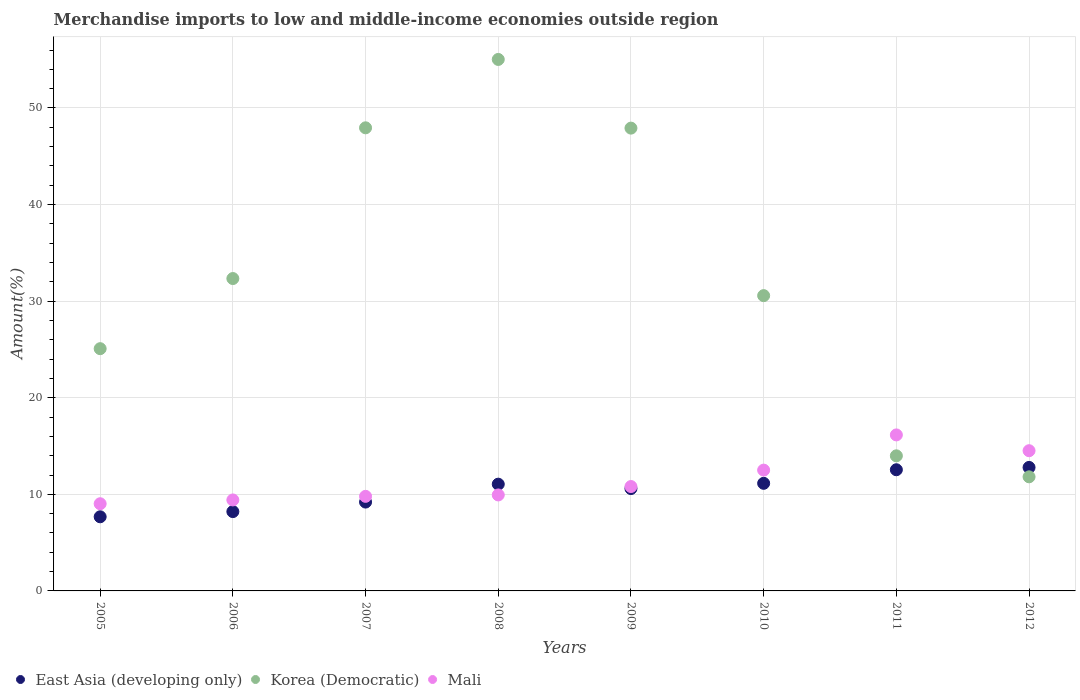How many different coloured dotlines are there?
Your response must be concise. 3. What is the percentage of amount earned from merchandise imports in Korea (Democratic) in 2011?
Make the answer very short. 13.99. Across all years, what is the maximum percentage of amount earned from merchandise imports in Mali?
Offer a very short reply. 16.15. Across all years, what is the minimum percentage of amount earned from merchandise imports in Mali?
Your response must be concise. 9.03. What is the total percentage of amount earned from merchandise imports in Mali in the graph?
Ensure brevity in your answer.  92.15. What is the difference between the percentage of amount earned from merchandise imports in Korea (Democratic) in 2005 and that in 2006?
Your answer should be very brief. -7.26. What is the difference between the percentage of amount earned from merchandise imports in Korea (Democratic) in 2007 and the percentage of amount earned from merchandise imports in Mali in 2009?
Keep it short and to the point. 37.14. What is the average percentage of amount earned from merchandise imports in East Asia (developing only) per year?
Give a very brief answer. 10.4. In the year 2007, what is the difference between the percentage of amount earned from merchandise imports in East Asia (developing only) and percentage of amount earned from merchandise imports in Korea (Democratic)?
Your answer should be very brief. -38.75. What is the ratio of the percentage of amount earned from merchandise imports in Mali in 2006 to that in 2011?
Your answer should be very brief. 0.58. Is the difference between the percentage of amount earned from merchandise imports in East Asia (developing only) in 2006 and 2011 greater than the difference between the percentage of amount earned from merchandise imports in Korea (Democratic) in 2006 and 2011?
Provide a succinct answer. No. What is the difference between the highest and the second highest percentage of amount earned from merchandise imports in Mali?
Your response must be concise. 1.64. What is the difference between the highest and the lowest percentage of amount earned from merchandise imports in East Asia (developing only)?
Provide a short and direct response. 5.11. Is it the case that in every year, the sum of the percentage of amount earned from merchandise imports in Mali and percentage of amount earned from merchandise imports in East Asia (developing only)  is greater than the percentage of amount earned from merchandise imports in Korea (Democratic)?
Your answer should be very brief. No. Is the percentage of amount earned from merchandise imports in Mali strictly less than the percentage of amount earned from merchandise imports in Korea (Democratic) over the years?
Give a very brief answer. No. How many dotlines are there?
Offer a very short reply. 3. Are the values on the major ticks of Y-axis written in scientific E-notation?
Your answer should be compact. No. Where does the legend appear in the graph?
Ensure brevity in your answer.  Bottom left. How many legend labels are there?
Provide a short and direct response. 3. What is the title of the graph?
Provide a succinct answer. Merchandise imports to low and middle-income economies outside region. What is the label or title of the Y-axis?
Your answer should be compact. Amount(%). What is the Amount(%) of East Asia (developing only) in 2005?
Your response must be concise. 7.68. What is the Amount(%) of Korea (Democratic) in 2005?
Your answer should be very brief. 25.08. What is the Amount(%) of Mali in 2005?
Offer a terse response. 9.03. What is the Amount(%) of East Asia (developing only) in 2006?
Offer a terse response. 8.21. What is the Amount(%) of Korea (Democratic) in 2006?
Offer a very short reply. 32.34. What is the Amount(%) of Mali in 2006?
Offer a very short reply. 9.42. What is the Amount(%) of East Asia (developing only) in 2007?
Provide a succinct answer. 9.2. What is the Amount(%) in Korea (Democratic) in 2007?
Your response must be concise. 47.94. What is the Amount(%) in Mali in 2007?
Your answer should be very brief. 9.79. What is the Amount(%) in East Asia (developing only) in 2008?
Provide a succinct answer. 11.05. What is the Amount(%) in Korea (Democratic) in 2008?
Make the answer very short. 55.02. What is the Amount(%) of Mali in 2008?
Offer a very short reply. 9.94. What is the Amount(%) in East Asia (developing only) in 2009?
Provide a succinct answer. 10.6. What is the Amount(%) of Korea (Democratic) in 2009?
Your answer should be compact. 47.91. What is the Amount(%) of Mali in 2009?
Offer a very short reply. 10.81. What is the Amount(%) of East Asia (developing only) in 2010?
Provide a succinct answer. 11.14. What is the Amount(%) in Korea (Democratic) in 2010?
Offer a terse response. 30.57. What is the Amount(%) in Mali in 2010?
Give a very brief answer. 12.51. What is the Amount(%) of East Asia (developing only) in 2011?
Give a very brief answer. 12.54. What is the Amount(%) of Korea (Democratic) in 2011?
Your answer should be very brief. 13.99. What is the Amount(%) of Mali in 2011?
Give a very brief answer. 16.15. What is the Amount(%) of East Asia (developing only) in 2012?
Make the answer very short. 12.79. What is the Amount(%) of Korea (Democratic) in 2012?
Keep it short and to the point. 11.81. What is the Amount(%) in Mali in 2012?
Provide a succinct answer. 14.52. Across all years, what is the maximum Amount(%) in East Asia (developing only)?
Offer a very short reply. 12.79. Across all years, what is the maximum Amount(%) in Korea (Democratic)?
Your answer should be compact. 55.02. Across all years, what is the maximum Amount(%) in Mali?
Your response must be concise. 16.15. Across all years, what is the minimum Amount(%) in East Asia (developing only)?
Provide a short and direct response. 7.68. Across all years, what is the minimum Amount(%) in Korea (Democratic)?
Make the answer very short. 11.81. Across all years, what is the minimum Amount(%) of Mali?
Provide a short and direct response. 9.03. What is the total Amount(%) in East Asia (developing only) in the graph?
Make the answer very short. 83.2. What is the total Amount(%) of Korea (Democratic) in the graph?
Your answer should be very brief. 264.67. What is the total Amount(%) of Mali in the graph?
Keep it short and to the point. 92.15. What is the difference between the Amount(%) in East Asia (developing only) in 2005 and that in 2006?
Your answer should be compact. -0.54. What is the difference between the Amount(%) in Korea (Democratic) in 2005 and that in 2006?
Your response must be concise. -7.26. What is the difference between the Amount(%) in Mali in 2005 and that in 2006?
Your answer should be compact. -0.39. What is the difference between the Amount(%) in East Asia (developing only) in 2005 and that in 2007?
Offer a terse response. -1.52. What is the difference between the Amount(%) in Korea (Democratic) in 2005 and that in 2007?
Your answer should be compact. -22.86. What is the difference between the Amount(%) in Mali in 2005 and that in 2007?
Your answer should be compact. -0.77. What is the difference between the Amount(%) of East Asia (developing only) in 2005 and that in 2008?
Offer a terse response. -3.38. What is the difference between the Amount(%) of Korea (Democratic) in 2005 and that in 2008?
Offer a very short reply. -29.94. What is the difference between the Amount(%) of Mali in 2005 and that in 2008?
Your answer should be very brief. -0.91. What is the difference between the Amount(%) in East Asia (developing only) in 2005 and that in 2009?
Keep it short and to the point. -2.92. What is the difference between the Amount(%) in Korea (Democratic) in 2005 and that in 2009?
Ensure brevity in your answer.  -22.83. What is the difference between the Amount(%) of Mali in 2005 and that in 2009?
Ensure brevity in your answer.  -1.78. What is the difference between the Amount(%) of East Asia (developing only) in 2005 and that in 2010?
Offer a terse response. -3.46. What is the difference between the Amount(%) in Korea (Democratic) in 2005 and that in 2010?
Provide a short and direct response. -5.49. What is the difference between the Amount(%) in Mali in 2005 and that in 2010?
Provide a short and direct response. -3.48. What is the difference between the Amount(%) of East Asia (developing only) in 2005 and that in 2011?
Provide a short and direct response. -4.87. What is the difference between the Amount(%) of Korea (Democratic) in 2005 and that in 2011?
Offer a terse response. 11.09. What is the difference between the Amount(%) in Mali in 2005 and that in 2011?
Provide a short and direct response. -7.13. What is the difference between the Amount(%) of East Asia (developing only) in 2005 and that in 2012?
Give a very brief answer. -5.11. What is the difference between the Amount(%) in Korea (Democratic) in 2005 and that in 2012?
Your answer should be compact. 13.27. What is the difference between the Amount(%) of Mali in 2005 and that in 2012?
Keep it short and to the point. -5.49. What is the difference between the Amount(%) in East Asia (developing only) in 2006 and that in 2007?
Provide a succinct answer. -0.99. What is the difference between the Amount(%) of Korea (Democratic) in 2006 and that in 2007?
Your answer should be very brief. -15.6. What is the difference between the Amount(%) of Mali in 2006 and that in 2007?
Your answer should be very brief. -0.37. What is the difference between the Amount(%) in East Asia (developing only) in 2006 and that in 2008?
Your response must be concise. -2.84. What is the difference between the Amount(%) in Korea (Democratic) in 2006 and that in 2008?
Your answer should be compact. -22.68. What is the difference between the Amount(%) of Mali in 2006 and that in 2008?
Your answer should be compact. -0.52. What is the difference between the Amount(%) of East Asia (developing only) in 2006 and that in 2009?
Keep it short and to the point. -2.39. What is the difference between the Amount(%) in Korea (Democratic) in 2006 and that in 2009?
Provide a succinct answer. -15.57. What is the difference between the Amount(%) in Mali in 2006 and that in 2009?
Provide a short and direct response. -1.39. What is the difference between the Amount(%) of East Asia (developing only) in 2006 and that in 2010?
Your answer should be compact. -2.93. What is the difference between the Amount(%) in Korea (Democratic) in 2006 and that in 2010?
Provide a succinct answer. 1.77. What is the difference between the Amount(%) of Mali in 2006 and that in 2010?
Provide a succinct answer. -3.09. What is the difference between the Amount(%) in East Asia (developing only) in 2006 and that in 2011?
Offer a very short reply. -4.33. What is the difference between the Amount(%) of Korea (Democratic) in 2006 and that in 2011?
Your response must be concise. 18.35. What is the difference between the Amount(%) of Mali in 2006 and that in 2011?
Offer a terse response. -6.73. What is the difference between the Amount(%) in East Asia (developing only) in 2006 and that in 2012?
Your answer should be very brief. -4.57. What is the difference between the Amount(%) of Korea (Democratic) in 2006 and that in 2012?
Give a very brief answer. 20.53. What is the difference between the Amount(%) in Mali in 2006 and that in 2012?
Provide a short and direct response. -5.1. What is the difference between the Amount(%) in East Asia (developing only) in 2007 and that in 2008?
Your response must be concise. -1.85. What is the difference between the Amount(%) of Korea (Democratic) in 2007 and that in 2008?
Your answer should be compact. -7.08. What is the difference between the Amount(%) in Mali in 2007 and that in 2008?
Keep it short and to the point. -0.15. What is the difference between the Amount(%) of East Asia (developing only) in 2007 and that in 2009?
Make the answer very short. -1.4. What is the difference between the Amount(%) of Korea (Democratic) in 2007 and that in 2009?
Your answer should be very brief. 0.03. What is the difference between the Amount(%) of Mali in 2007 and that in 2009?
Ensure brevity in your answer.  -1.02. What is the difference between the Amount(%) of East Asia (developing only) in 2007 and that in 2010?
Give a very brief answer. -1.94. What is the difference between the Amount(%) in Korea (Democratic) in 2007 and that in 2010?
Provide a succinct answer. 17.37. What is the difference between the Amount(%) of Mali in 2007 and that in 2010?
Ensure brevity in your answer.  -2.72. What is the difference between the Amount(%) in East Asia (developing only) in 2007 and that in 2011?
Your response must be concise. -3.35. What is the difference between the Amount(%) of Korea (Democratic) in 2007 and that in 2011?
Make the answer very short. 33.96. What is the difference between the Amount(%) of Mali in 2007 and that in 2011?
Provide a succinct answer. -6.36. What is the difference between the Amount(%) of East Asia (developing only) in 2007 and that in 2012?
Ensure brevity in your answer.  -3.59. What is the difference between the Amount(%) in Korea (Democratic) in 2007 and that in 2012?
Your answer should be compact. 36.13. What is the difference between the Amount(%) of Mali in 2007 and that in 2012?
Offer a very short reply. -4.73. What is the difference between the Amount(%) of East Asia (developing only) in 2008 and that in 2009?
Offer a very short reply. 0.46. What is the difference between the Amount(%) of Korea (Democratic) in 2008 and that in 2009?
Provide a succinct answer. 7.11. What is the difference between the Amount(%) in Mali in 2008 and that in 2009?
Your answer should be compact. -0.87. What is the difference between the Amount(%) of East Asia (developing only) in 2008 and that in 2010?
Your answer should be very brief. -0.09. What is the difference between the Amount(%) of Korea (Democratic) in 2008 and that in 2010?
Provide a short and direct response. 24.45. What is the difference between the Amount(%) in Mali in 2008 and that in 2010?
Offer a terse response. -2.57. What is the difference between the Amount(%) of East Asia (developing only) in 2008 and that in 2011?
Your answer should be very brief. -1.49. What is the difference between the Amount(%) in Korea (Democratic) in 2008 and that in 2011?
Provide a short and direct response. 41.04. What is the difference between the Amount(%) in Mali in 2008 and that in 2011?
Your response must be concise. -6.21. What is the difference between the Amount(%) in East Asia (developing only) in 2008 and that in 2012?
Your answer should be very brief. -1.73. What is the difference between the Amount(%) of Korea (Democratic) in 2008 and that in 2012?
Give a very brief answer. 43.21. What is the difference between the Amount(%) in Mali in 2008 and that in 2012?
Your answer should be compact. -4.58. What is the difference between the Amount(%) in East Asia (developing only) in 2009 and that in 2010?
Provide a short and direct response. -0.54. What is the difference between the Amount(%) of Korea (Democratic) in 2009 and that in 2010?
Make the answer very short. 17.34. What is the difference between the Amount(%) of East Asia (developing only) in 2009 and that in 2011?
Your answer should be very brief. -1.95. What is the difference between the Amount(%) of Korea (Democratic) in 2009 and that in 2011?
Your response must be concise. 33.93. What is the difference between the Amount(%) of Mali in 2009 and that in 2011?
Offer a terse response. -5.34. What is the difference between the Amount(%) in East Asia (developing only) in 2009 and that in 2012?
Offer a terse response. -2.19. What is the difference between the Amount(%) in Korea (Democratic) in 2009 and that in 2012?
Offer a terse response. 36.1. What is the difference between the Amount(%) of Mali in 2009 and that in 2012?
Offer a terse response. -3.71. What is the difference between the Amount(%) of East Asia (developing only) in 2010 and that in 2011?
Ensure brevity in your answer.  -1.41. What is the difference between the Amount(%) in Korea (Democratic) in 2010 and that in 2011?
Offer a terse response. 16.59. What is the difference between the Amount(%) of Mali in 2010 and that in 2011?
Provide a short and direct response. -3.64. What is the difference between the Amount(%) in East Asia (developing only) in 2010 and that in 2012?
Make the answer very short. -1.65. What is the difference between the Amount(%) in Korea (Democratic) in 2010 and that in 2012?
Your response must be concise. 18.76. What is the difference between the Amount(%) in Mali in 2010 and that in 2012?
Your answer should be compact. -2.01. What is the difference between the Amount(%) in East Asia (developing only) in 2011 and that in 2012?
Your response must be concise. -0.24. What is the difference between the Amount(%) of Korea (Democratic) in 2011 and that in 2012?
Your answer should be very brief. 2.17. What is the difference between the Amount(%) of Mali in 2011 and that in 2012?
Your response must be concise. 1.64. What is the difference between the Amount(%) of East Asia (developing only) in 2005 and the Amount(%) of Korea (Democratic) in 2006?
Your response must be concise. -24.66. What is the difference between the Amount(%) in East Asia (developing only) in 2005 and the Amount(%) in Mali in 2006?
Give a very brief answer. -1.74. What is the difference between the Amount(%) of Korea (Democratic) in 2005 and the Amount(%) of Mali in 2006?
Provide a succinct answer. 15.66. What is the difference between the Amount(%) of East Asia (developing only) in 2005 and the Amount(%) of Korea (Democratic) in 2007?
Give a very brief answer. -40.27. What is the difference between the Amount(%) in East Asia (developing only) in 2005 and the Amount(%) in Mali in 2007?
Keep it short and to the point. -2.12. What is the difference between the Amount(%) of Korea (Democratic) in 2005 and the Amount(%) of Mali in 2007?
Give a very brief answer. 15.29. What is the difference between the Amount(%) in East Asia (developing only) in 2005 and the Amount(%) in Korea (Democratic) in 2008?
Your response must be concise. -47.35. What is the difference between the Amount(%) of East Asia (developing only) in 2005 and the Amount(%) of Mali in 2008?
Offer a very short reply. -2.26. What is the difference between the Amount(%) of Korea (Democratic) in 2005 and the Amount(%) of Mali in 2008?
Your answer should be compact. 15.14. What is the difference between the Amount(%) in East Asia (developing only) in 2005 and the Amount(%) in Korea (Democratic) in 2009?
Provide a short and direct response. -40.24. What is the difference between the Amount(%) of East Asia (developing only) in 2005 and the Amount(%) of Mali in 2009?
Provide a succinct answer. -3.13. What is the difference between the Amount(%) in Korea (Democratic) in 2005 and the Amount(%) in Mali in 2009?
Give a very brief answer. 14.27. What is the difference between the Amount(%) in East Asia (developing only) in 2005 and the Amount(%) in Korea (Democratic) in 2010?
Provide a succinct answer. -22.9. What is the difference between the Amount(%) of East Asia (developing only) in 2005 and the Amount(%) of Mali in 2010?
Offer a terse response. -4.83. What is the difference between the Amount(%) in Korea (Democratic) in 2005 and the Amount(%) in Mali in 2010?
Offer a very short reply. 12.57. What is the difference between the Amount(%) of East Asia (developing only) in 2005 and the Amount(%) of Korea (Democratic) in 2011?
Give a very brief answer. -6.31. What is the difference between the Amount(%) in East Asia (developing only) in 2005 and the Amount(%) in Mali in 2011?
Provide a succinct answer. -8.48. What is the difference between the Amount(%) of Korea (Democratic) in 2005 and the Amount(%) of Mali in 2011?
Your answer should be very brief. 8.93. What is the difference between the Amount(%) in East Asia (developing only) in 2005 and the Amount(%) in Korea (Democratic) in 2012?
Your answer should be very brief. -4.14. What is the difference between the Amount(%) in East Asia (developing only) in 2005 and the Amount(%) in Mali in 2012?
Give a very brief answer. -6.84. What is the difference between the Amount(%) in Korea (Democratic) in 2005 and the Amount(%) in Mali in 2012?
Keep it short and to the point. 10.56. What is the difference between the Amount(%) in East Asia (developing only) in 2006 and the Amount(%) in Korea (Democratic) in 2007?
Your response must be concise. -39.73. What is the difference between the Amount(%) in East Asia (developing only) in 2006 and the Amount(%) in Mali in 2007?
Your answer should be very brief. -1.58. What is the difference between the Amount(%) of Korea (Democratic) in 2006 and the Amount(%) of Mali in 2007?
Your response must be concise. 22.55. What is the difference between the Amount(%) in East Asia (developing only) in 2006 and the Amount(%) in Korea (Democratic) in 2008?
Offer a very short reply. -46.81. What is the difference between the Amount(%) in East Asia (developing only) in 2006 and the Amount(%) in Mali in 2008?
Provide a short and direct response. -1.73. What is the difference between the Amount(%) in Korea (Democratic) in 2006 and the Amount(%) in Mali in 2008?
Your response must be concise. 22.4. What is the difference between the Amount(%) of East Asia (developing only) in 2006 and the Amount(%) of Korea (Democratic) in 2009?
Provide a short and direct response. -39.7. What is the difference between the Amount(%) in East Asia (developing only) in 2006 and the Amount(%) in Mali in 2009?
Provide a succinct answer. -2.6. What is the difference between the Amount(%) of Korea (Democratic) in 2006 and the Amount(%) of Mali in 2009?
Keep it short and to the point. 21.53. What is the difference between the Amount(%) of East Asia (developing only) in 2006 and the Amount(%) of Korea (Democratic) in 2010?
Offer a very short reply. -22.36. What is the difference between the Amount(%) of East Asia (developing only) in 2006 and the Amount(%) of Mali in 2010?
Your response must be concise. -4.3. What is the difference between the Amount(%) of Korea (Democratic) in 2006 and the Amount(%) of Mali in 2010?
Provide a succinct answer. 19.83. What is the difference between the Amount(%) in East Asia (developing only) in 2006 and the Amount(%) in Korea (Democratic) in 2011?
Keep it short and to the point. -5.77. What is the difference between the Amount(%) of East Asia (developing only) in 2006 and the Amount(%) of Mali in 2011?
Provide a succinct answer. -7.94. What is the difference between the Amount(%) in Korea (Democratic) in 2006 and the Amount(%) in Mali in 2011?
Offer a terse response. 16.19. What is the difference between the Amount(%) in East Asia (developing only) in 2006 and the Amount(%) in Korea (Democratic) in 2012?
Keep it short and to the point. -3.6. What is the difference between the Amount(%) in East Asia (developing only) in 2006 and the Amount(%) in Mali in 2012?
Your answer should be compact. -6.3. What is the difference between the Amount(%) of Korea (Democratic) in 2006 and the Amount(%) of Mali in 2012?
Your answer should be very brief. 17.82. What is the difference between the Amount(%) of East Asia (developing only) in 2007 and the Amount(%) of Korea (Democratic) in 2008?
Offer a very short reply. -45.82. What is the difference between the Amount(%) in East Asia (developing only) in 2007 and the Amount(%) in Mali in 2008?
Offer a very short reply. -0.74. What is the difference between the Amount(%) in Korea (Democratic) in 2007 and the Amount(%) in Mali in 2008?
Make the answer very short. 38.01. What is the difference between the Amount(%) in East Asia (developing only) in 2007 and the Amount(%) in Korea (Democratic) in 2009?
Give a very brief answer. -38.71. What is the difference between the Amount(%) in East Asia (developing only) in 2007 and the Amount(%) in Mali in 2009?
Provide a succinct answer. -1.61. What is the difference between the Amount(%) in Korea (Democratic) in 2007 and the Amount(%) in Mali in 2009?
Your answer should be very brief. 37.14. What is the difference between the Amount(%) of East Asia (developing only) in 2007 and the Amount(%) of Korea (Democratic) in 2010?
Keep it short and to the point. -21.37. What is the difference between the Amount(%) in East Asia (developing only) in 2007 and the Amount(%) in Mali in 2010?
Your response must be concise. -3.31. What is the difference between the Amount(%) of Korea (Democratic) in 2007 and the Amount(%) of Mali in 2010?
Make the answer very short. 35.44. What is the difference between the Amount(%) in East Asia (developing only) in 2007 and the Amount(%) in Korea (Democratic) in 2011?
Your answer should be very brief. -4.79. What is the difference between the Amount(%) in East Asia (developing only) in 2007 and the Amount(%) in Mali in 2011?
Offer a terse response. -6.95. What is the difference between the Amount(%) in Korea (Democratic) in 2007 and the Amount(%) in Mali in 2011?
Offer a terse response. 31.79. What is the difference between the Amount(%) of East Asia (developing only) in 2007 and the Amount(%) of Korea (Democratic) in 2012?
Offer a terse response. -2.61. What is the difference between the Amount(%) in East Asia (developing only) in 2007 and the Amount(%) in Mali in 2012?
Offer a very short reply. -5.32. What is the difference between the Amount(%) in Korea (Democratic) in 2007 and the Amount(%) in Mali in 2012?
Your answer should be compact. 33.43. What is the difference between the Amount(%) of East Asia (developing only) in 2008 and the Amount(%) of Korea (Democratic) in 2009?
Your answer should be compact. -36.86. What is the difference between the Amount(%) in East Asia (developing only) in 2008 and the Amount(%) in Mali in 2009?
Your answer should be compact. 0.25. What is the difference between the Amount(%) in Korea (Democratic) in 2008 and the Amount(%) in Mali in 2009?
Give a very brief answer. 44.22. What is the difference between the Amount(%) of East Asia (developing only) in 2008 and the Amount(%) of Korea (Democratic) in 2010?
Your response must be concise. -19.52. What is the difference between the Amount(%) in East Asia (developing only) in 2008 and the Amount(%) in Mali in 2010?
Your response must be concise. -1.45. What is the difference between the Amount(%) in Korea (Democratic) in 2008 and the Amount(%) in Mali in 2010?
Provide a short and direct response. 42.52. What is the difference between the Amount(%) in East Asia (developing only) in 2008 and the Amount(%) in Korea (Democratic) in 2011?
Make the answer very short. -2.93. What is the difference between the Amount(%) in East Asia (developing only) in 2008 and the Amount(%) in Mali in 2011?
Your response must be concise. -5.1. What is the difference between the Amount(%) in Korea (Democratic) in 2008 and the Amount(%) in Mali in 2011?
Your answer should be compact. 38.87. What is the difference between the Amount(%) in East Asia (developing only) in 2008 and the Amount(%) in Korea (Democratic) in 2012?
Your answer should be compact. -0.76. What is the difference between the Amount(%) of East Asia (developing only) in 2008 and the Amount(%) of Mali in 2012?
Provide a succinct answer. -3.46. What is the difference between the Amount(%) in Korea (Democratic) in 2008 and the Amount(%) in Mali in 2012?
Give a very brief answer. 40.51. What is the difference between the Amount(%) of East Asia (developing only) in 2009 and the Amount(%) of Korea (Democratic) in 2010?
Your answer should be very brief. -19.97. What is the difference between the Amount(%) in East Asia (developing only) in 2009 and the Amount(%) in Mali in 2010?
Your answer should be very brief. -1.91. What is the difference between the Amount(%) in Korea (Democratic) in 2009 and the Amount(%) in Mali in 2010?
Make the answer very short. 35.41. What is the difference between the Amount(%) in East Asia (developing only) in 2009 and the Amount(%) in Korea (Democratic) in 2011?
Give a very brief answer. -3.39. What is the difference between the Amount(%) of East Asia (developing only) in 2009 and the Amount(%) of Mali in 2011?
Your response must be concise. -5.55. What is the difference between the Amount(%) in Korea (Democratic) in 2009 and the Amount(%) in Mali in 2011?
Provide a short and direct response. 31.76. What is the difference between the Amount(%) in East Asia (developing only) in 2009 and the Amount(%) in Korea (Democratic) in 2012?
Make the answer very short. -1.22. What is the difference between the Amount(%) of East Asia (developing only) in 2009 and the Amount(%) of Mali in 2012?
Provide a succinct answer. -3.92. What is the difference between the Amount(%) in Korea (Democratic) in 2009 and the Amount(%) in Mali in 2012?
Ensure brevity in your answer.  33.4. What is the difference between the Amount(%) in East Asia (developing only) in 2010 and the Amount(%) in Korea (Democratic) in 2011?
Make the answer very short. -2.85. What is the difference between the Amount(%) of East Asia (developing only) in 2010 and the Amount(%) of Mali in 2011?
Make the answer very short. -5.01. What is the difference between the Amount(%) of Korea (Democratic) in 2010 and the Amount(%) of Mali in 2011?
Keep it short and to the point. 14.42. What is the difference between the Amount(%) in East Asia (developing only) in 2010 and the Amount(%) in Korea (Democratic) in 2012?
Your answer should be very brief. -0.67. What is the difference between the Amount(%) in East Asia (developing only) in 2010 and the Amount(%) in Mali in 2012?
Ensure brevity in your answer.  -3.38. What is the difference between the Amount(%) of Korea (Democratic) in 2010 and the Amount(%) of Mali in 2012?
Your response must be concise. 16.05. What is the difference between the Amount(%) in East Asia (developing only) in 2011 and the Amount(%) in Korea (Democratic) in 2012?
Your response must be concise. 0.73. What is the difference between the Amount(%) of East Asia (developing only) in 2011 and the Amount(%) of Mali in 2012?
Offer a terse response. -1.97. What is the difference between the Amount(%) of Korea (Democratic) in 2011 and the Amount(%) of Mali in 2012?
Your response must be concise. -0.53. What is the average Amount(%) in East Asia (developing only) per year?
Keep it short and to the point. 10.4. What is the average Amount(%) in Korea (Democratic) per year?
Give a very brief answer. 33.08. What is the average Amount(%) in Mali per year?
Offer a terse response. 11.52. In the year 2005, what is the difference between the Amount(%) in East Asia (developing only) and Amount(%) in Korea (Democratic)?
Your response must be concise. -17.4. In the year 2005, what is the difference between the Amount(%) in East Asia (developing only) and Amount(%) in Mali?
Your answer should be very brief. -1.35. In the year 2005, what is the difference between the Amount(%) in Korea (Democratic) and Amount(%) in Mali?
Make the answer very short. 16.05. In the year 2006, what is the difference between the Amount(%) in East Asia (developing only) and Amount(%) in Korea (Democratic)?
Keep it short and to the point. -24.13. In the year 2006, what is the difference between the Amount(%) of East Asia (developing only) and Amount(%) of Mali?
Your answer should be very brief. -1.21. In the year 2006, what is the difference between the Amount(%) of Korea (Democratic) and Amount(%) of Mali?
Offer a very short reply. 22.92. In the year 2007, what is the difference between the Amount(%) in East Asia (developing only) and Amount(%) in Korea (Democratic)?
Your answer should be compact. -38.75. In the year 2007, what is the difference between the Amount(%) of East Asia (developing only) and Amount(%) of Mali?
Ensure brevity in your answer.  -0.59. In the year 2007, what is the difference between the Amount(%) in Korea (Democratic) and Amount(%) in Mali?
Make the answer very short. 38.15. In the year 2008, what is the difference between the Amount(%) in East Asia (developing only) and Amount(%) in Korea (Democratic)?
Your answer should be very brief. -43.97. In the year 2008, what is the difference between the Amount(%) of East Asia (developing only) and Amount(%) of Mali?
Keep it short and to the point. 1.12. In the year 2008, what is the difference between the Amount(%) of Korea (Democratic) and Amount(%) of Mali?
Your answer should be very brief. 45.09. In the year 2009, what is the difference between the Amount(%) of East Asia (developing only) and Amount(%) of Korea (Democratic)?
Make the answer very short. -37.32. In the year 2009, what is the difference between the Amount(%) in East Asia (developing only) and Amount(%) in Mali?
Your response must be concise. -0.21. In the year 2009, what is the difference between the Amount(%) of Korea (Democratic) and Amount(%) of Mali?
Make the answer very short. 37.11. In the year 2010, what is the difference between the Amount(%) in East Asia (developing only) and Amount(%) in Korea (Democratic)?
Your answer should be compact. -19.43. In the year 2010, what is the difference between the Amount(%) in East Asia (developing only) and Amount(%) in Mali?
Your response must be concise. -1.37. In the year 2010, what is the difference between the Amount(%) in Korea (Democratic) and Amount(%) in Mali?
Keep it short and to the point. 18.06. In the year 2011, what is the difference between the Amount(%) in East Asia (developing only) and Amount(%) in Korea (Democratic)?
Make the answer very short. -1.44. In the year 2011, what is the difference between the Amount(%) in East Asia (developing only) and Amount(%) in Mali?
Give a very brief answer. -3.61. In the year 2011, what is the difference between the Amount(%) in Korea (Democratic) and Amount(%) in Mali?
Keep it short and to the point. -2.17. In the year 2012, what is the difference between the Amount(%) of East Asia (developing only) and Amount(%) of Korea (Democratic)?
Provide a short and direct response. 0.97. In the year 2012, what is the difference between the Amount(%) in East Asia (developing only) and Amount(%) in Mali?
Ensure brevity in your answer.  -1.73. In the year 2012, what is the difference between the Amount(%) of Korea (Democratic) and Amount(%) of Mali?
Provide a short and direct response. -2.7. What is the ratio of the Amount(%) of East Asia (developing only) in 2005 to that in 2006?
Your response must be concise. 0.93. What is the ratio of the Amount(%) of Korea (Democratic) in 2005 to that in 2006?
Ensure brevity in your answer.  0.78. What is the ratio of the Amount(%) of Mali in 2005 to that in 2006?
Ensure brevity in your answer.  0.96. What is the ratio of the Amount(%) in East Asia (developing only) in 2005 to that in 2007?
Ensure brevity in your answer.  0.83. What is the ratio of the Amount(%) in Korea (Democratic) in 2005 to that in 2007?
Make the answer very short. 0.52. What is the ratio of the Amount(%) in Mali in 2005 to that in 2007?
Offer a very short reply. 0.92. What is the ratio of the Amount(%) in East Asia (developing only) in 2005 to that in 2008?
Make the answer very short. 0.69. What is the ratio of the Amount(%) of Korea (Democratic) in 2005 to that in 2008?
Your answer should be very brief. 0.46. What is the ratio of the Amount(%) of Mali in 2005 to that in 2008?
Your response must be concise. 0.91. What is the ratio of the Amount(%) of East Asia (developing only) in 2005 to that in 2009?
Your answer should be very brief. 0.72. What is the ratio of the Amount(%) in Korea (Democratic) in 2005 to that in 2009?
Provide a short and direct response. 0.52. What is the ratio of the Amount(%) of Mali in 2005 to that in 2009?
Give a very brief answer. 0.84. What is the ratio of the Amount(%) in East Asia (developing only) in 2005 to that in 2010?
Offer a terse response. 0.69. What is the ratio of the Amount(%) in Korea (Democratic) in 2005 to that in 2010?
Your answer should be very brief. 0.82. What is the ratio of the Amount(%) of Mali in 2005 to that in 2010?
Your answer should be very brief. 0.72. What is the ratio of the Amount(%) of East Asia (developing only) in 2005 to that in 2011?
Offer a very short reply. 0.61. What is the ratio of the Amount(%) in Korea (Democratic) in 2005 to that in 2011?
Offer a very short reply. 1.79. What is the ratio of the Amount(%) of Mali in 2005 to that in 2011?
Give a very brief answer. 0.56. What is the ratio of the Amount(%) of East Asia (developing only) in 2005 to that in 2012?
Give a very brief answer. 0.6. What is the ratio of the Amount(%) in Korea (Democratic) in 2005 to that in 2012?
Offer a terse response. 2.12. What is the ratio of the Amount(%) in Mali in 2005 to that in 2012?
Provide a short and direct response. 0.62. What is the ratio of the Amount(%) of East Asia (developing only) in 2006 to that in 2007?
Ensure brevity in your answer.  0.89. What is the ratio of the Amount(%) of Korea (Democratic) in 2006 to that in 2007?
Provide a short and direct response. 0.67. What is the ratio of the Amount(%) in Mali in 2006 to that in 2007?
Your answer should be very brief. 0.96. What is the ratio of the Amount(%) of East Asia (developing only) in 2006 to that in 2008?
Make the answer very short. 0.74. What is the ratio of the Amount(%) of Korea (Democratic) in 2006 to that in 2008?
Provide a short and direct response. 0.59. What is the ratio of the Amount(%) in Mali in 2006 to that in 2008?
Your response must be concise. 0.95. What is the ratio of the Amount(%) of East Asia (developing only) in 2006 to that in 2009?
Ensure brevity in your answer.  0.77. What is the ratio of the Amount(%) in Korea (Democratic) in 2006 to that in 2009?
Your response must be concise. 0.68. What is the ratio of the Amount(%) of Mali in 2006 to that in 2009?
Provide a succinct answer. 0.87. What is the ratio of the Amount(%) of East Asia (developing only) in 2006 to that in 2010?
Offer a very short reply. 0.74. What is the ratio of the Amount(%) in Korea (Democratic) in 2006 to that in 2010?
Provide a short and direct response. 1.06. What is the ratio of the Amount(%) in Mali in 2006 to that in 2010?
Your answer should be very brief. 0.75. What is the ratio of the Amount(%) of East Asia (developing only) in 2006 to that in 2011?
Offer a very short reply. 0.65. What is the ratio of the Amount(%) in Korea (Democratic) in 2006 to that in 2011?
Your answer should be compact. 2.31. What is the ratio of the Amount(%) of Mali in 2006 to that in 2011?
Give a very brief answer. 0.58. What is the ratio of the Amount(%) in East Asia (developing only) in 2006 to that in 2012?
Offer a terse response. 0.64. What is the ratio of the Amount(%) of Korea (Democratic) in 2006 to that in 2012?
Give a very brief answer. 2.74. What is the ratio of the Amount(%) in Mali in 2006 to that in 2012?
Offer a terse response. 0.65. What is the ratio of the Amount(%) of East Asia (developing only) in 2007 to that in 2008?
Keep it short and to the point. 0.83. What is the ratio of the Amount(%) of Korea (Democratic) in 2007 to that in 2008?
Give a very brief answer. 0.87. What is the ratio of the Amount(%) in East Asia (developing only) in 2007 to that in 2009?
Your answer should be compact. 0.87. What is the ratio of the Amount(%) in Korea (Democratic) in 2007 to that in 2009?
Provide a short and direct response. 1. What is the ratio of the Amount(%) in Mali in 2007 to that in 2009?
Give a very brief answer. 0.91. What is the ratio of the Amount(%) in East Asia (developing only) in 2007 to that in 2010?
Give a very brief answer. 0.83. What is the ratio of the Amount(%) in Korea (Democratic) in 2007 to that in 2010?
Keep it short and to the point. 1.57. What is the ratio of the Amount(%) in Mali in 2007 to that in 2010?
Provide a succinct answer. 0.78. What is the ratio of the Amount(%) of East Asia (developing only) in 2007 to that in 2011?
Provide a succinct answer. 0.73. What is the ratio of the Amount(%) in Korea (Democratic) in 2007 to that in 2011?
Provide a succinct answer. 3.43. What is the ratio of the Amount(%) in Mali in 2007 to that in 2011?
Give a very brief answer. 0.61. What is the ratio of the Amount(%) in East Asia (developing only) in 2007 to that in 2012?
Provide a succinct answer. 0.72. What is the ratio of the Amount(%) in Korea (Democratic) in 2007 to that in 2012?
Offer a very short reply. 4.06. What is the ratio of the Amount(%) of Mali in 2007 to that in 2012?
Your response must be concise. 0.67. What is the ratio of the Amount(%) of East Asia (developing only) in 2008 to that in 2009?
Your answer should be compact. 1.04. What is the ratio of the Amount(%) in Korea (Democratic) in 2008 to that in 2009?
Make the answer very short. 1.15. What is the ratio of the Amount(%) of Mali in 2008 to that in 2009?
Your response must be concise. 0.92. What is the ratio of the Amount(%) in Korea (Democratic) in 2008 to that in 2010?
Your answer should be compact. 1.8. What is the ratio of the Amount(%) of Mali in 2008 to that in 2010?
Offer a terse response. 0.79. What is the ratio of the Amount(%) in East Asia (developing only) in 2008 to that in 2011?
Ensure brevity in your answer.  0.88. What is the ratio of the Amount(%) of Korea (Democratic) in 2008 to that in 2011?
Give a very brief answer. 3.93. What is the ratio of the Amount(%) in Mali in 2008 to that in 2011?
Give a very brief answer. 0.62. What is the ratio of the Amount(%) in East Asia (developing only) in 2008 to that in 2012?
Give a very brief answer. 0.86. What is the ratio of the Amount(%) of Korea (Democratic) in 2008 to that in 2012?
Ensure brevity in your answer.  4.66. What is the ratio of the Amount(%) in Mali in 2008 to that in 2012?
Give a very brief answer. 0.68. What is the ratio of the Amount(%) in East Asia (developing only) in 2009 to that in 2010?
Keep it short and to the point. 0.95. What is the ratio of the Amount(%) of Korea (Democratic) in 2009 to that in 2010?
Give a very brief answer. 1.57. What is the ratio of the Amount(%) in Mali in 2009 to that in 2010?
Make the answer very short. 0.86. What is the ratio of the Amount(%) of East Asia (developing only) in 2009 to that in 2011?
Provide a short and direct response. 0.84. What is the ratio of the Amount(%) in Korea (Democratic) in 2009 to that in 2011?
Provide a succinct answer. 3.43. What is the ratio of the Amount(%) in Mali in 2009 to that in 2011?
Give a very brief answer. 0.67. What is the ratio of the Amount(%) of East Asia (developing only) in 2009 to that in 2012?
Provide a succinct answer. 0.83. What is the ratio of the Amount(%) of Korea (Democratic) in 2009 to that in 2012?
Provide a succinct answer. 4.06. What is the ratio of the Amount(%) of Mali in 2009 to that in 2012?
Your answer should be very brief. 0.74. What is the ratio of the Amount(%) of East Asia (developing only) in 2010 to that in 2011?
Provide a short and direct response. 0.89. What is the ratio of the Amount(%) of Korea (Democratic) in 2010 to that in 2011?
Offer a terse response. 2.19. What is the ratio of the Amount(%) in Mali in 2010 to that in 2011?
Provide a short and direct response. 0.77. What is the ratio of the Amount(%) in East Asia (developing only) in 2010 to that in 2012?
Your answer should be very brief. 0.87. What is the ratio of the Amount(%) of Korea (Democratic) in 2010 to that in 2012?
Make the answer very short. 2.59. What is the ratio of the Amount(%) in Mali in 2010 to that in 2012?
Give a very brief answer. 0.86. What is the ratio of the Amount(%) in East Asia (developing only) in 2011 to that in 2012?
Make the answer very short. 0.98. What is the ratio of the Amount(%) of Korea (Democratic) in 2011 to that in 2012?
Provide a short and direct response. 1.18. What is the ratio of the Amount(%) of Mali in 2011 to that in 2012?
Provide a short and direct response. 1.11. What is the difference between the highest and the second highest Amount(%) of East Asia (developing only)?
Offer a terse response. 0.24. What is the difference between the highest and the second highest Amount(%) of Korea (Democratic)?
Provide a succinct answer. 7.08. What is the difference between the highest and the second highest Amount(%) in Mali?
Provide a short and direct response. 1.64. What is the difference between the highest and the lowest Amount(%) of East Asia (developing only)?
Your response must be concise. 5.11. What is the difference between the highest and the lowest Amount(%) in Korea (Democratic)?
Provide a short and direct response. 43.21. What is the difference between the highest and the lowest Amount(%) in Mali?
Offer a very short reply. 7.13. 